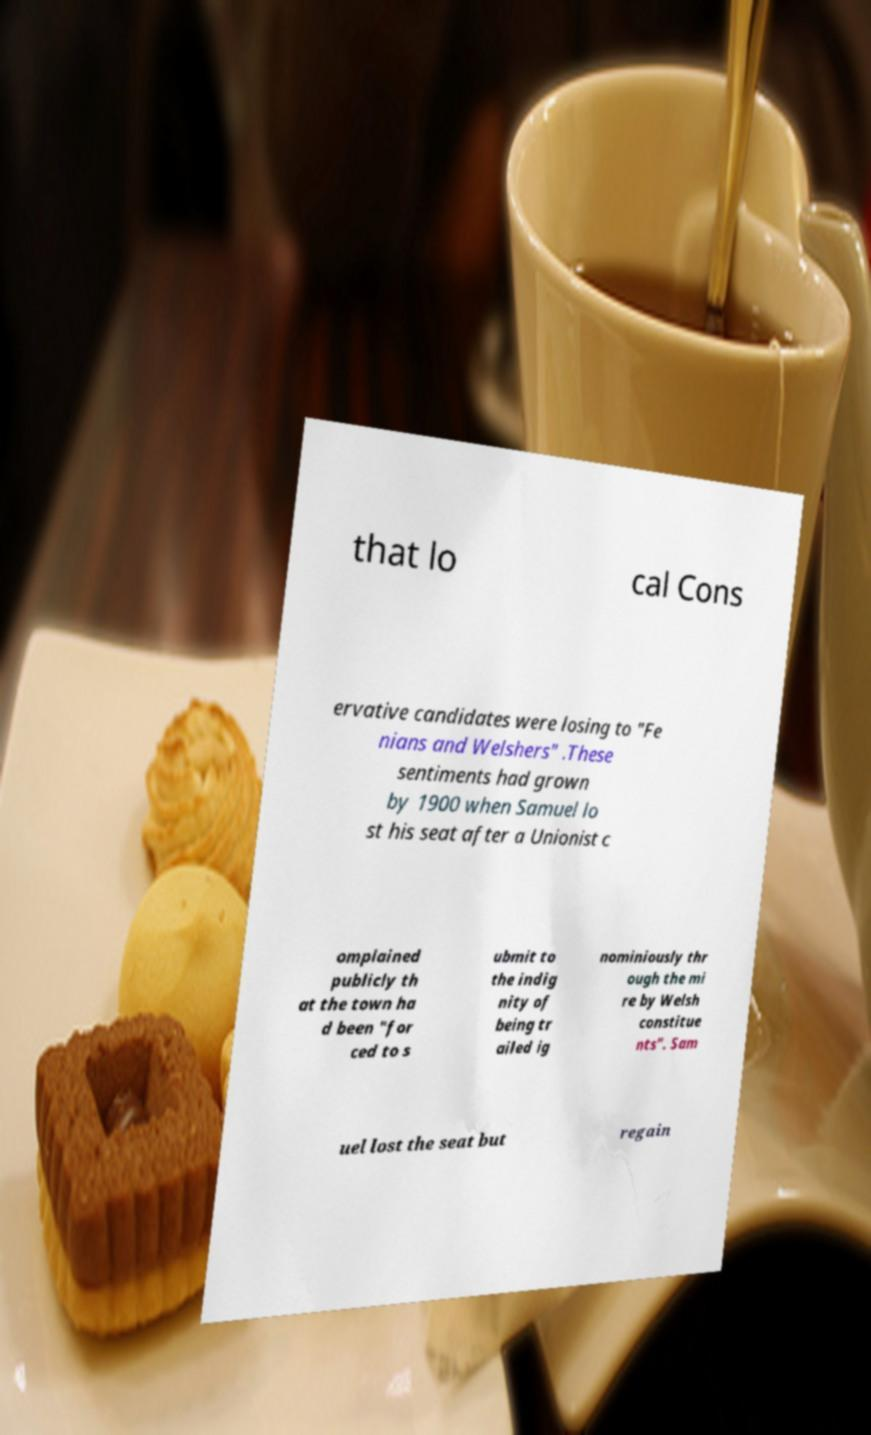Please read and relay the text visible in this image. What does it say? that lo cal Cons ervative candidates were losing to "Fe nians and Welshers" .These sentiments had grown by 1900 when Samuel lo st his seat after a Unionist c omplained publicly th at the town ha d been "for ced to s ubmit to the indig nity of being tr ailed ig nominiously thr ough the mi re by Welsh constitue nts". Sam uel lost the seat but regain 